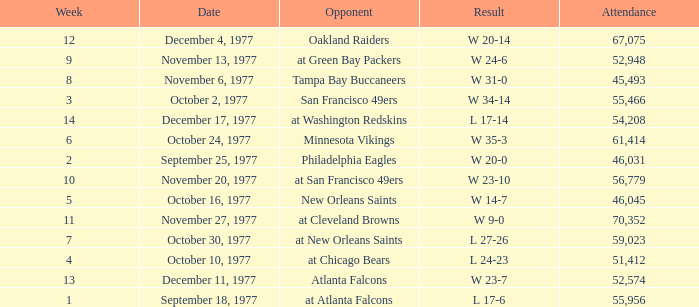What is the lowest attendance for week 2? 46031.0. 